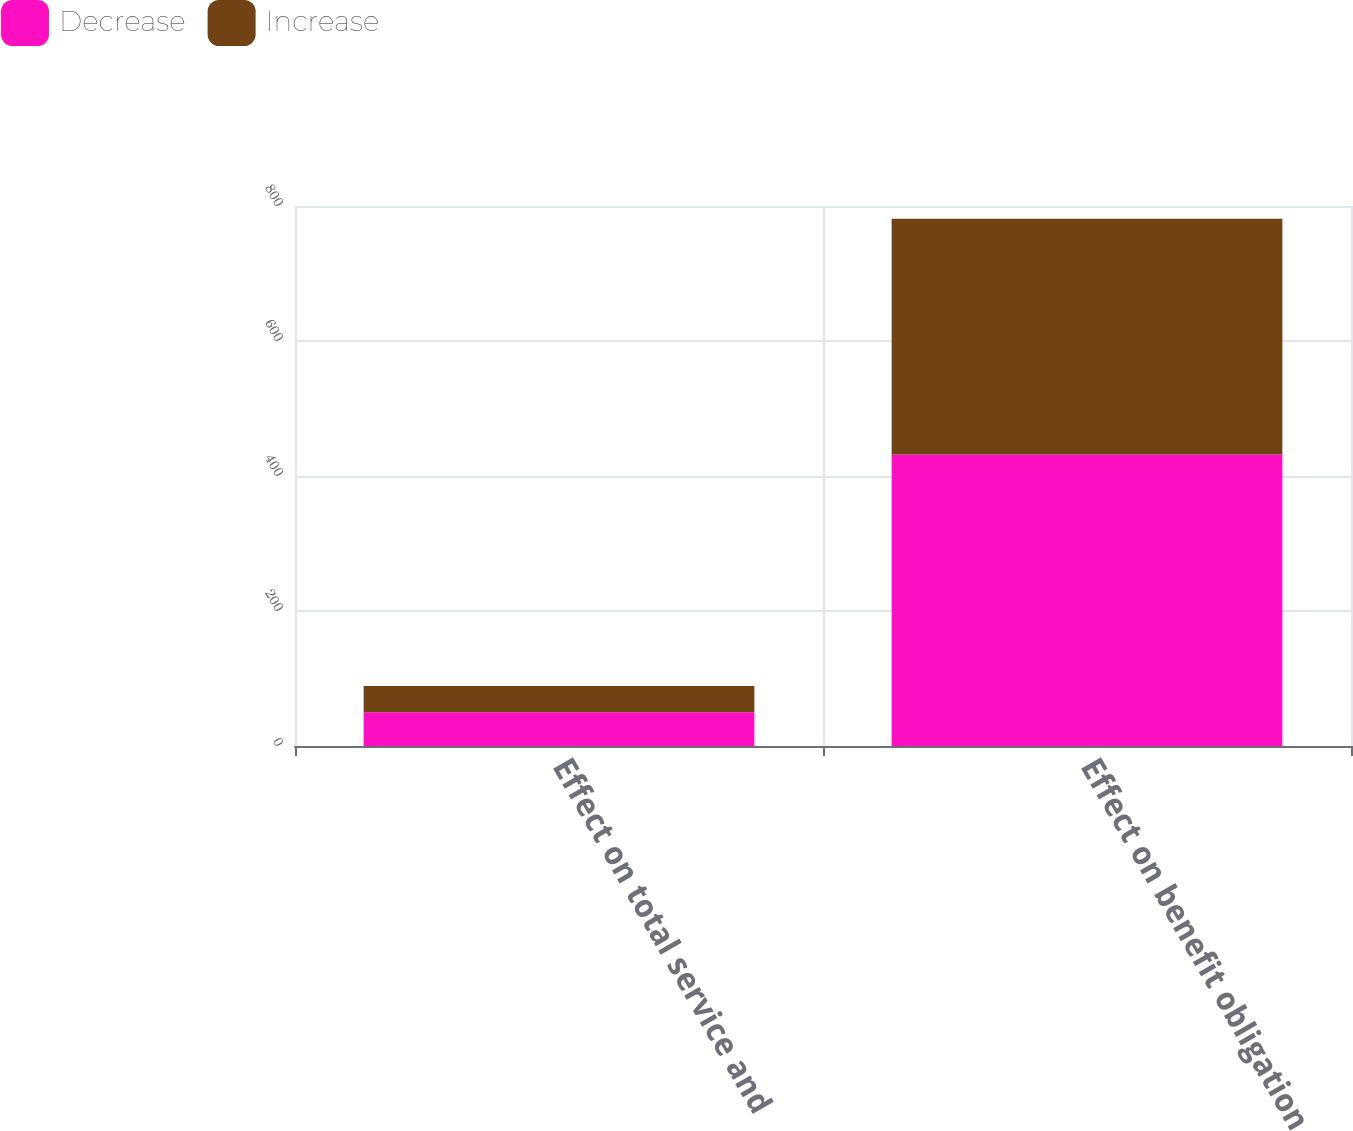<chart> <loc_0><loc_0><loc_500><loc_500><stacked_bar_chart><ecel><fcel>Effect on total service and<fcel>Effect on benefit obligation<nl><fcel>Decrease<fcel>50<fcel>432<nl><fcel>Increase<fcel>39<fcel>349<nl></chart> 